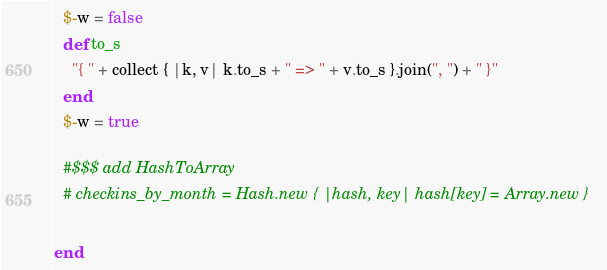Convert code to text. <code><loc_0><loc_0><loc_500><loc_500><_Ruby_>
  $-w = false
  def to_s
    "{ " + collect { |k, v| k.to_s + " => " + v.to_s }.join(", ") + " }"
  end
  $-w = true

  #$$$ add HashToArray
  # checkins_by_month = Hash.new { |hash, key| hash[key] = Array.new }

end
</code> 